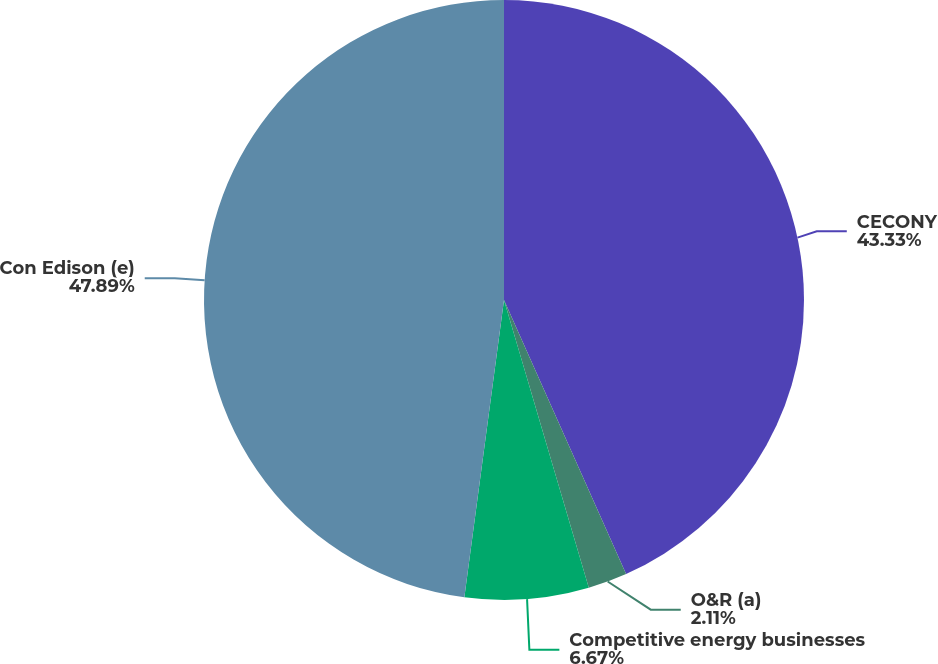Convert chart to OTSL. <chart><loc_0><loc_0><loc_500><loc_500><pie_chart><fcel>CECONY<fcel>O&R (a)<fcel>Competitive energy businesses<fcel>Con Edison (e)<nl><fcel>43.33%<fcel>2.11%<fcel>6.67%<fcel>47.89%<nl></chart> 